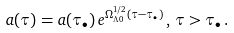<formula> <loc_0><loc_0><loc_500><loc_500>a ( \tau ) = a ( \tau _ { \bullet } ) \, e ^ { \Omega _ { \Lambda 0 } ^ { 1 / 2 } ( \tau - \tau _ { \bullet } ) } \, , \, \tau > \tau _ { \bullet } \, .</formula> 